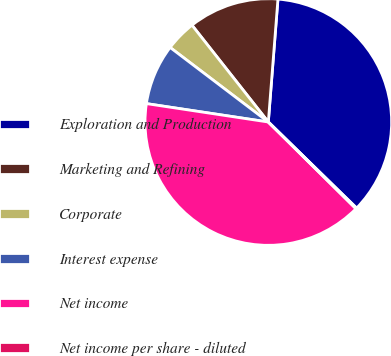Convert chart. <chart><loc_0><loc_0><loc_500><loc_500><pie_chart><fcel>Exploration and Production<fcel>Marketing and Refining<fcel>Corporate<fcel>Interest expense<fcel>Net income<fcel>Net income per share - diluted<nl><fcel>36.05%<fcel>11.87%<fcel>4.04%<fcel>7.95%<fcel>39.97%<fcel>0.12%<nl></chart> 